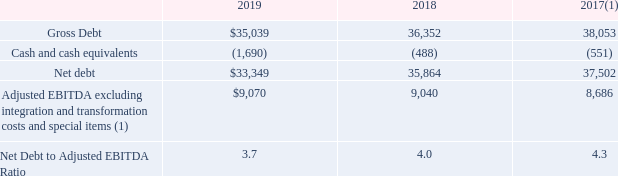Net Debt to Adjusted EBITDA Ratio
(UNAUDITED)
($ in millions)
(1) 2017 Adjusted EBITDA shown pro forma, assuming the Level 3 acquisition and the colocation and data center sale took place on January 1, 2017.
What is the assumption for the 2017 adjusted EBITDA shown pro forma? The level 3 acquisition and the colocation and data center sale took place on january 1, 2017. What is the gross debt in 2019?
Answer scale should be: million. $35,039. Which years does the table show the Net Debt to Adjusted EBITDA Ratio? 2019, 2018, 2017. What is the change in gross debt in 2019 from 2018?
Answer scale should be: million. $35,039-$36,352
Answer: -1313. What is the total gross debt over the three years?
Answer scale should be: million. $35,039+$36,352+$38,053
Answer: 109444. What is the percentage change in gross debt in 2019 from 2018?
Answer scale should be: percent. ($35,039-$36,352)/$36,352
Answer: -3.61. 